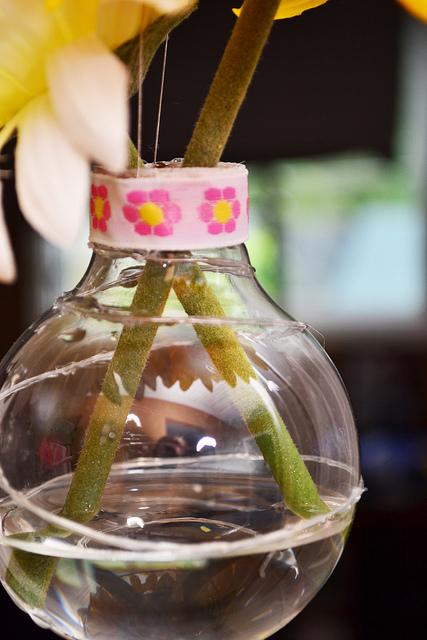Did the glass item used to be a light bulb?
Short answer required. Yes. Is the water in the vase dirty?
Quick response, please. No. What pattern is on the ribbon around the neck of the vase?
Quick response, please. Flowers. 